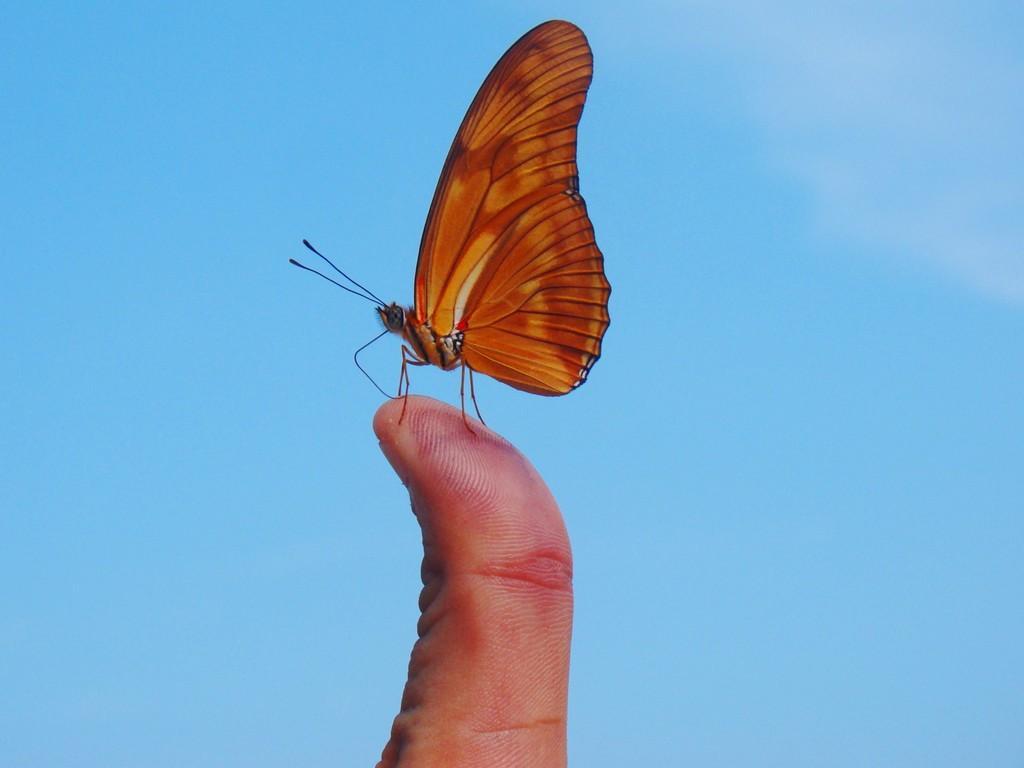Could you give a brief overview of what you see in this image? In the picture we can see a butterfly standing on the person's finger and the butterfly is yellow and reddish color with legs and antenna and in the background we can see a sky which is blue in color. 